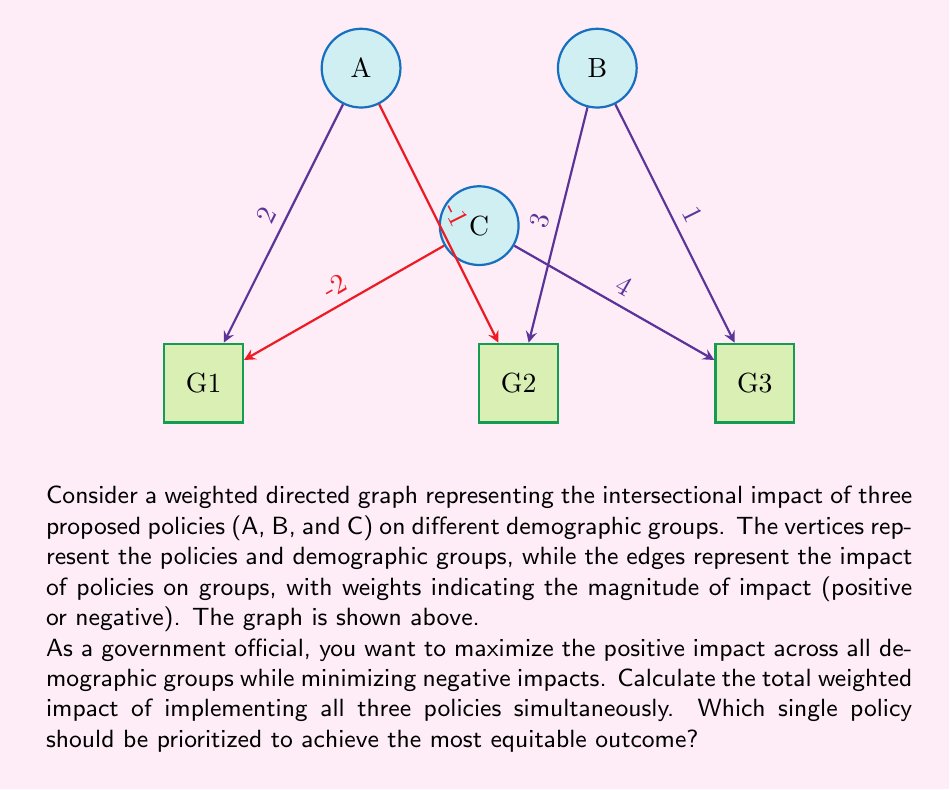Can you answer this question? To solve this problem, we'll follow these steps:

1. Calculate the total weighted impact:
   - Sum all edge weights in the graph
   $$ \text{Total Impact} = 2 + (-1) + 3 + 1 + (-2) + 4 = 7 $$

2. Analyze the impact of each policy:
   - Policy A: $2 + (-1) = 1$
   - Policy B: $3 + 1 = 4$
   - Policy C: $(-2) + 4 = 2$

3. Consider equity:
   - Policy A affects 2 groups (G1 positively, G2 negatively)
   - Policy B affects 2 groups (G2 and G3 positively)
   - Policy C affects 2 groups (G1 negatively, G3 positively)

4. Evaluate for the most equitable outcome:
   - Policy B has the highest positive impact (4) and only positive effects
   - It affects multiple groups without causing negative impacts
   - Prioritizing B would lead to the most equitable outcome among the three policies

Therefore, Policy B should be prioritized to achieve the most equitable outcome while maximizing positive impact across demographic groups.
Answer: Total weighted impact: 7; Prioritize Policy B 